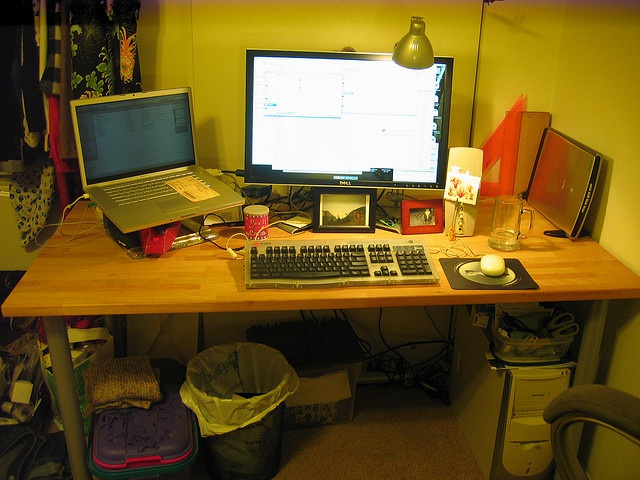Describe the objects in this image and their specific colors. I can see tv in black, white, and darkgreen tones, laptop in black, teal, and olive tones, keyboard in black, olive, and gold tones, laptop in black, brown, maroon, and olive tones, and chair in black and olive tones in this image. 